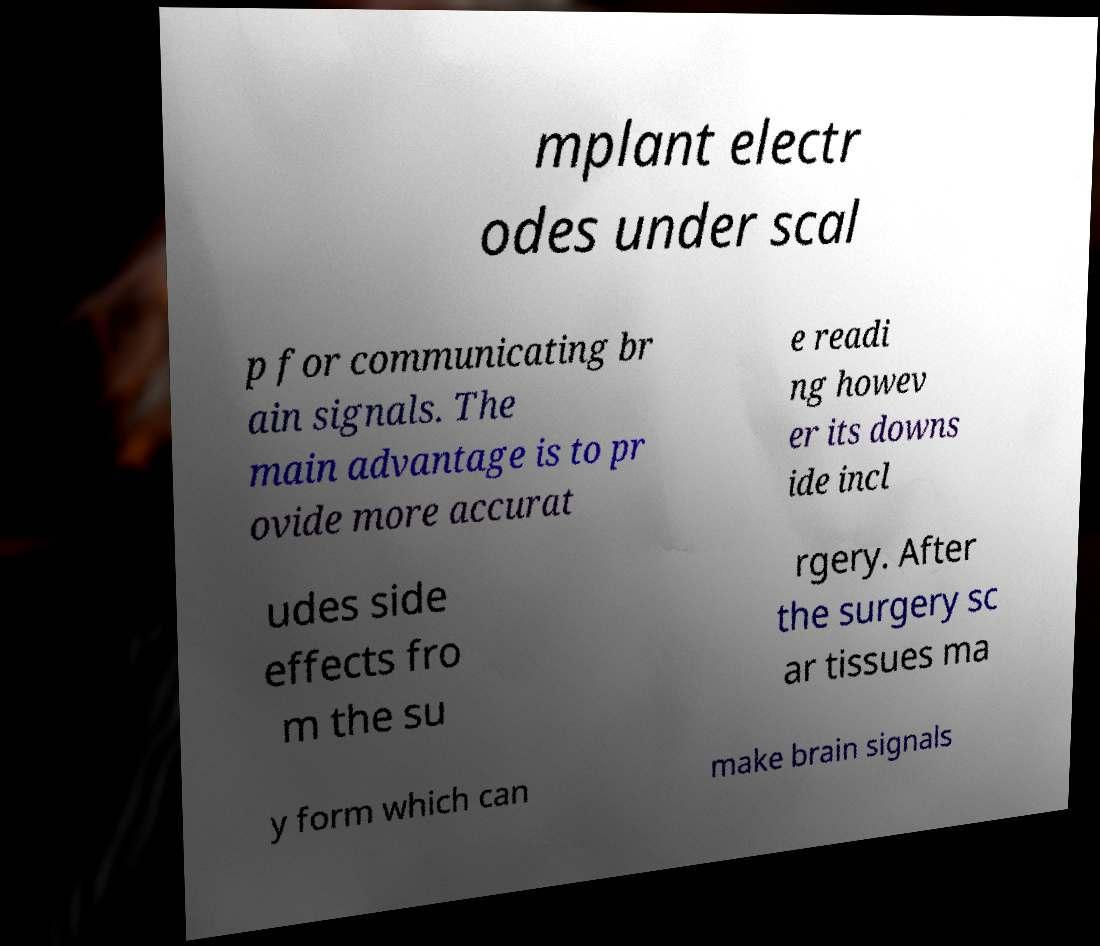What messages or text are displayed in this image? I need them in a readable, typed format. mplant electr odes under scal p for communicating br ain signals. The main advantage is to pr ovide more accurat e readi ng howev er its downs ide incl udes side effects fro m the su rgery. After the surgery sc ar tissues ma y form which can make brain signals 